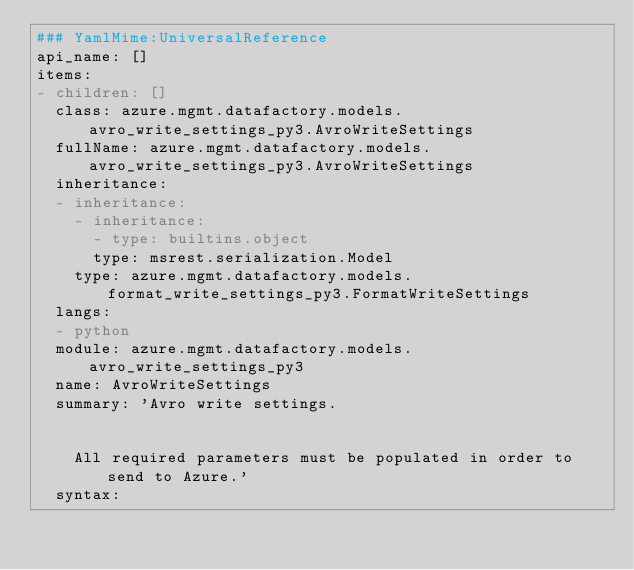Convert code to text. <code><loc_0><loc_0><loc_500><loc_500><_YAML_>### YamlMime:UniversalReference
api_name: []
items:
- children: []
  class: azure.mgmt.datafactory.models.avro_write_settings_py3.AvroWriteSettings
  fullName: azure.mgmt.datafactory.models.avro_write_settings_py3.AvroWriteSettings
  inheritance:
  - inheritance:
    - inheritance:
      - type: builtins.object
      type: msrest.serialization.Model
    type: azure.mgmt.datafactory.models.format_write_settings_py3.FormatWriteSettings
  langs:
  - python
  module: azure.mgmt.datafactory.models.avro_write_settings_py3
  name: AvroWriteSettings
  summary: 'Avro write settings.


    All required parameters must be populated in order to send to Azure.'
  syntax:</code> 